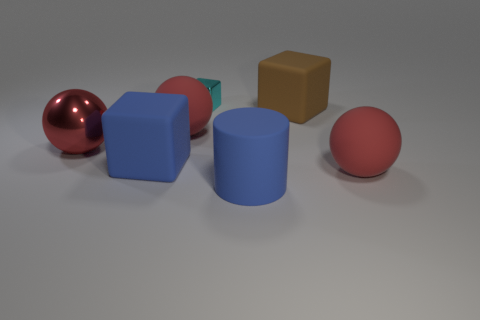Is there anything else that is the same size as the cyan metal block?
Keep it short and to the point. No. Is there a brown thing made of the same material as the cylinder?
Provide a succinct answer. Yes. Are there any large rubber objects that are to the left of the rubber sphere that is on the left side of the brown matte cube?
Give a very brief answer. Yes. There is a cyan cube that is behind the large blue cylinder; what is it made of?
Give a very brief answer. Metal. Is the cyan object the same shape as the brown rubber object?
Provide a succinct answer. Yes. What color is the matte cube in front of the large red sphere left of the sphere that is behind the red metallic object?
Provide a succinct answer. Blue. How many tiny cyan shiny things have the same shape as the large brown thing?
Offer a very short reply. 1. There is a cyan shiny block to the right of the blue rubber object that is on the left side of the shiny block; what is its size?
Your response must be concise. Small. Is the size of the matte cylinder the same as the cyan metallic cube?
Your response must be concise. No. There is a red rubber thing left of the large red ball that is on the right side of the brown rubber object; is there a large red matte ball right of it?
Offer a very short reply. Yes. 